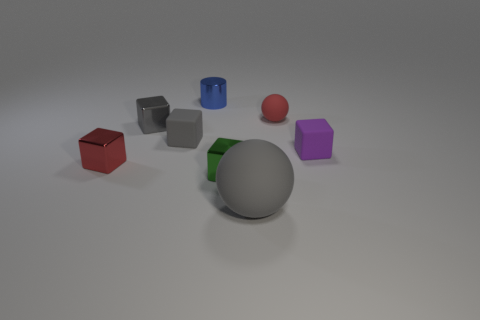Are the green cube and the red sphere made of the same material?
Keep it short and to the point. No. What number of objects are balls that are in front of the small purple thing or spheres in front of the tiny purple matte object?
Provide a short and direct response. 1. Are there any other balls of the same size as the red rubber sphere?
Ensure brevity in your answer.  No. There is another rubber thing that is the same shape as the small gray rubber thing; what color is it?
Offer a terse response. Purple. Is there a tiny blue shiny thing behind the ball that is on the right side of the big rubber thing?
Your response must be concise. Yes. Do the rubber object left of the green metal block and the green thing have the same shape?
Provide a short and direct response. Yes. What shape is the green object?
Your response must be concise. Cube. What number of big gray objects have the same material as the big sphere?
Make the answer very short. 0. Do the big rubber ball and the sphere behind the big ball have the same color?
Your answer should be compact. No. How many small objects are there?
Offer a terse response. 7. 